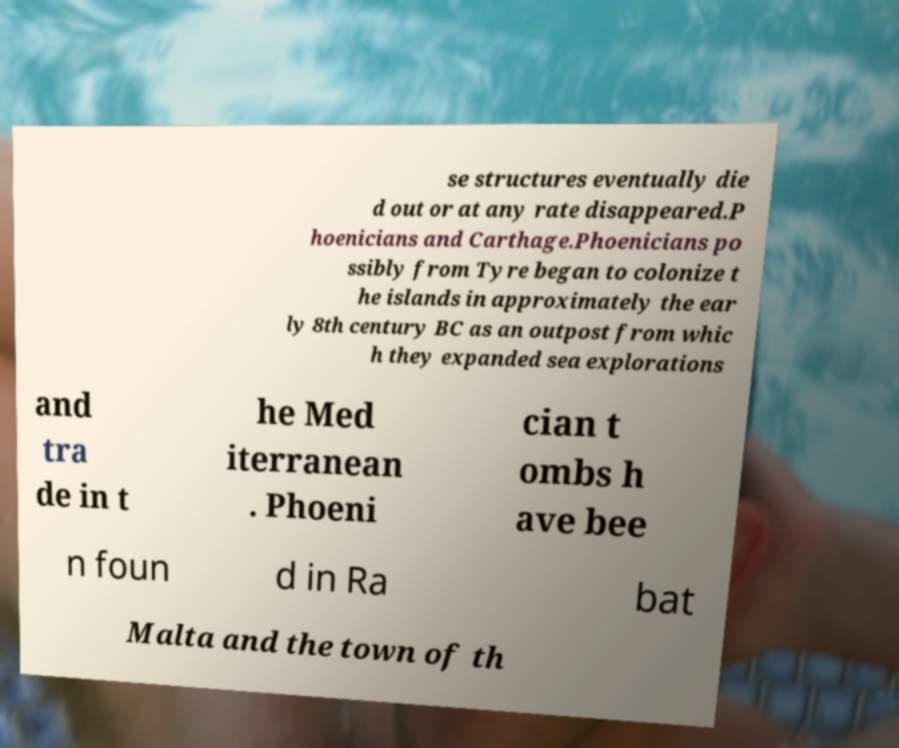There's text embedded in this image that I need extracted. Can you transcribe it verbatim? se structures eventually die d out or at any rate disappeared.P hoenicians and Carthage.Phoenicians po ssibly from Tyre began to colonize t he islands in approximately the ear ly 8th century BC as an outpost from whic h they expanded sea explorations and tra de in t he Med iterranean . Phoeni cian t ombs h ave bee n foun d in Ra bat Malta and the town of th 